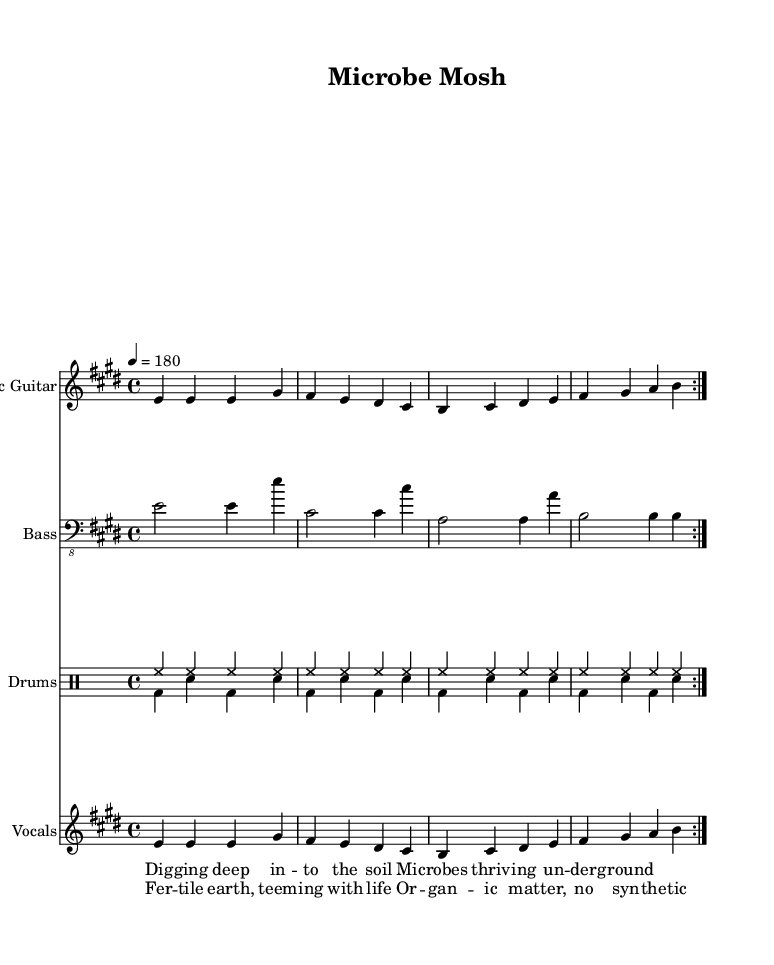What is the key signature of this music? The key signature is E major, which has four sharps: F#, C#, G#, and D#. This can be identified in the beginning of the sheet music after the \key directive.
Answer: E major What is the time signature of this music? The time signature is 4/4, indicated at the start of the sheet music right after the key signature. This means there are four beats per measure, and the quarter note gets one beat.
Answer: 4/4 What is the tempo of this music? The tempo is 180 beats per minute, as stated at the beginning of the sheet music following the \tempo directive. This indicates how fast the music should be played.
Answer: 180 How many times is the verse repeated? The verse is repeated twice, as indicated by the \repeat volta 2 directive in the lyrics section of the sheet music. This shows that the music for the verse will play two times before moving on.
Answer: 2 What type of drums are used in this song? The drums used are a bass drum and snare drum, which are typical in punk music for creating a driving beat. They are distinguished in the drum notation provided under \drummode.
Answer: Bass and snare What is the overall theme of the lyrics in this song? The overall theme of the lyrics celebrates soil health and the abundance of microorganisms, as expressed in phrases like "Digging deep into the soil" and "Teeming with life." This reflects a focus on organic matter and soil ecology.
Answer: Soil health What musical genre does this sheet music represent? This sheet music represents the punk genre, characterized by its fast tempo, simple chord progressions, and often socially or environmentally conscious lyrics. The high energy and specific musical structure align it with punk music conventions.
Answer: Punk 